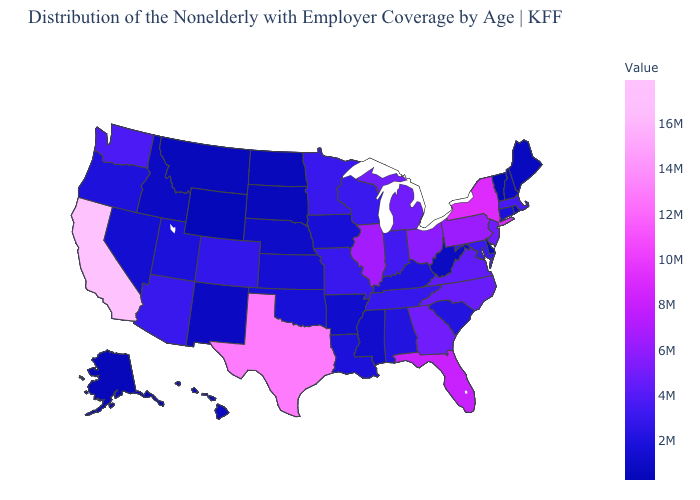Among the states that border Iowa , does Illinois have the highest value?
Concise answer only. Yes. Does North Dakota have the lowest value in the MidWest?
Be succinct. Yes. Among the states that border Louisiana , does Texas have the highest value?
Answer briefly. Yes. Does Vermont have the lowest value in the USA?
Keep it brief. Yes. Among the states that border Nebraska , which have the highest value?
Concise answer only. Missouri. Does Rhode Island have the lowest value in the USA?
Be succinct. No. 